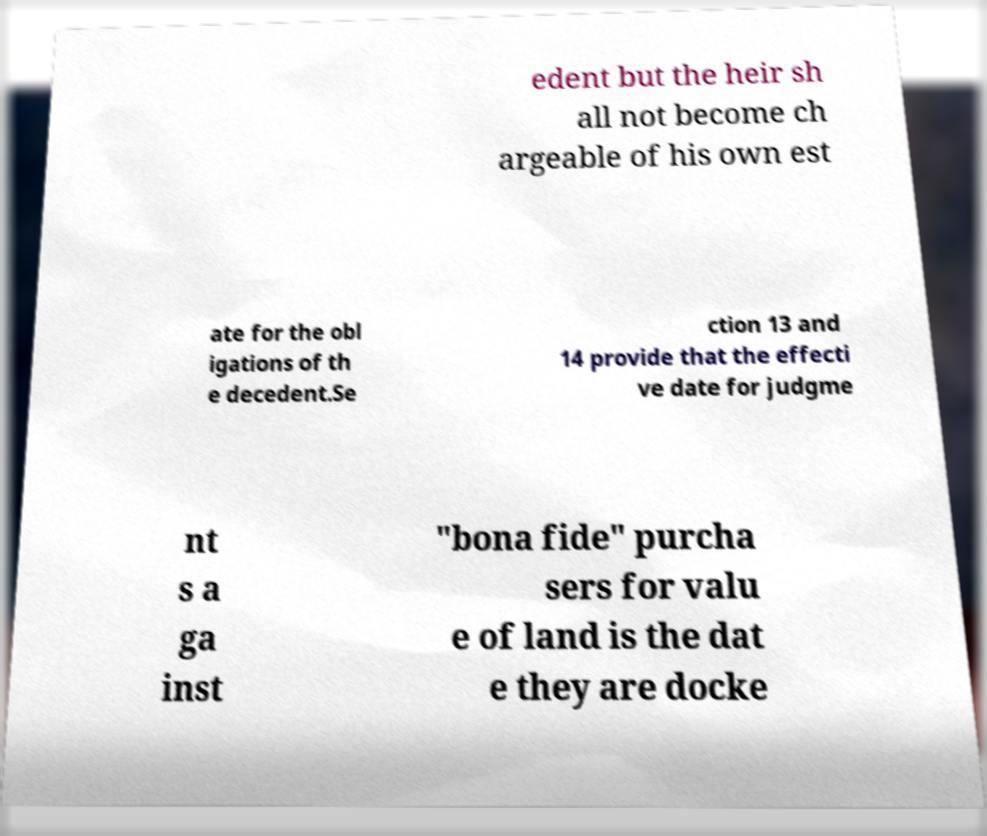Could you assist in decoding the text presented in this image and type it out clearly? edent but the heir sh all not become ch argeable of his own est ate for the obl igations of th e decedent.Se ction 13 and 14 provide that the effecti ve date for judgme nt s a ga inst "bona fide" purcha sers for valu e of land is the dat e they are docke 